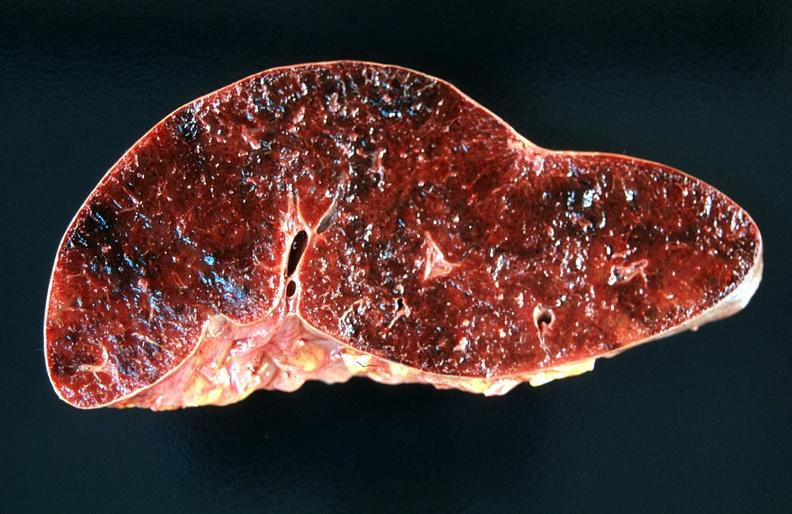where is this part in?
Answer the question using a single word or phrase. Spleen 